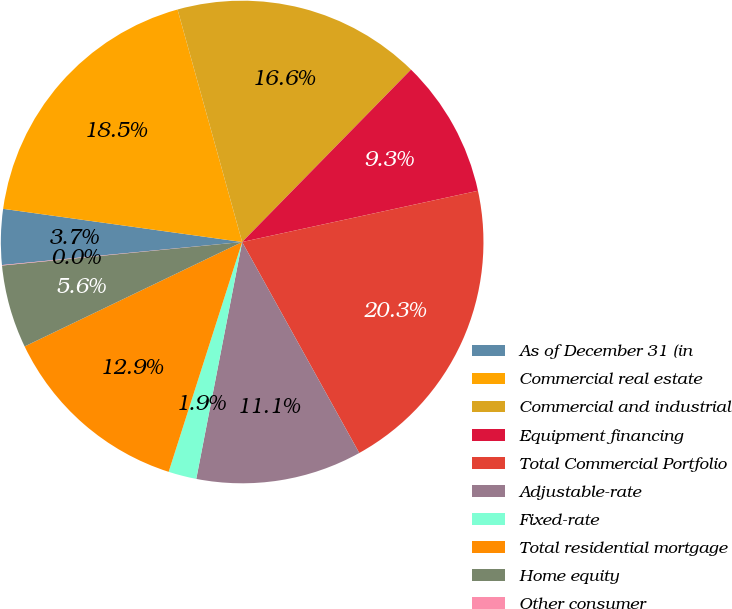Convert chart to OTSL. <chart><loc_0><loc_0><loc_500><loc_500><pie_chart><fcel>As of December 31 (in<fcel>Commercial real estate<fcel>Commercial and industrial<fcel>Equipment financing<fcel>Total Commercial Portfolio<fcel>Adjustable-rate<fcel>Fixed-rate<fcel>Total residential mortgage<fcel>Home equity<fcel>Other consumer<nl><fcel>3.72%<fcel>18.49%<fcel>16.65%<fcel>9.26%<fcel>20.34%<fcel>11.11%<fcel>1.88%<fcel>12.95%<fcel>5.57%<fcel>0.03%<nl></chart> 